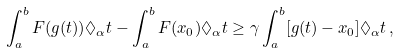Convert formula to latex. <formula><loc_0><loc_0><loc_500><loc_500>\int _ { a } ^ { b } F ( g ( t ) ) \Diamond _ { \alpha } t - \int _ { a } ^ { b } F ( x _ { 0 } ) \Diamond _ { \alpha } t \geq \gamma \int _ { a } ^ { b } [ g ( t ) - x _ { 0 } ] \Diamond _ { \alpha } t \, ,</formula> 